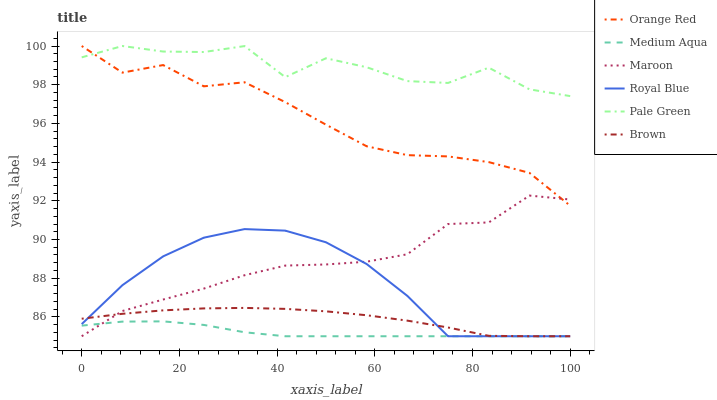Does Medium Aqua have the minimum area under the curve?
Answer yes or no. Yes. Does Pale Green have the maximum area under the curve?
Answer yes or no. Yes. Does Maroon have the minimum area under the curve?
Answer yes or no. No. Does Maroon have the maximum area under the curve?
Answer yes or no. No. Is Medium Aqua the smoothest?
Answer yes or no. Yes. Is Pale Green the roughest?
Answer yes or no. Yes. Is Maroon the smoothest?
Answer yes or no. No. Is Maroon the roughest?
Answer yes or no. No. Does Brown have the lowest value?
Answer yes or no. Yes. Does Pale Green have the lowest value?
Answer yes or no. No. Does Orange Red have the highest value?
Answer yes or no. Yes. Does Maroon have the highest value?
Answer yes or no. No. Is Royal Blue less than Orange Red?
Answer yes or no. Yes. Is Pale Green greater than Brown?
Answer yes or no. Yes. Does Pale Green intersect Orange Red?
Answer yes or no. Yes. Is Pale Green less than Orange Red?
Answer yes or no. No. Is Pale Green greater than Orange Red?
Answer yes or no. No. Does Royal Blue intersect Orange Red?
Answer yes or no. No. 